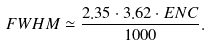<formula> <loc_0><loc_0><loc_500><loc_500>F W H M \simeq \frac { 2 . 3 5 \cdot 3 . 6 2 \cdot E N C } { 1 0 0 0 } .</formula> 